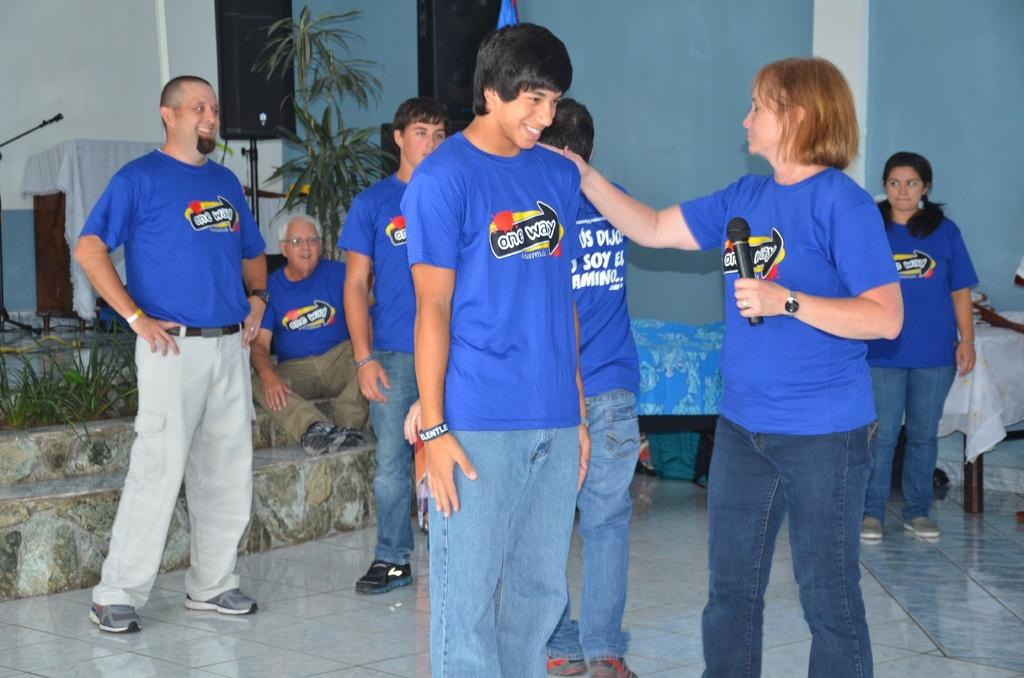<image>
Create a compact narrative representing the image presented. A woman is touching another person's shoulder and both are wearing shirts that say one way on them. 